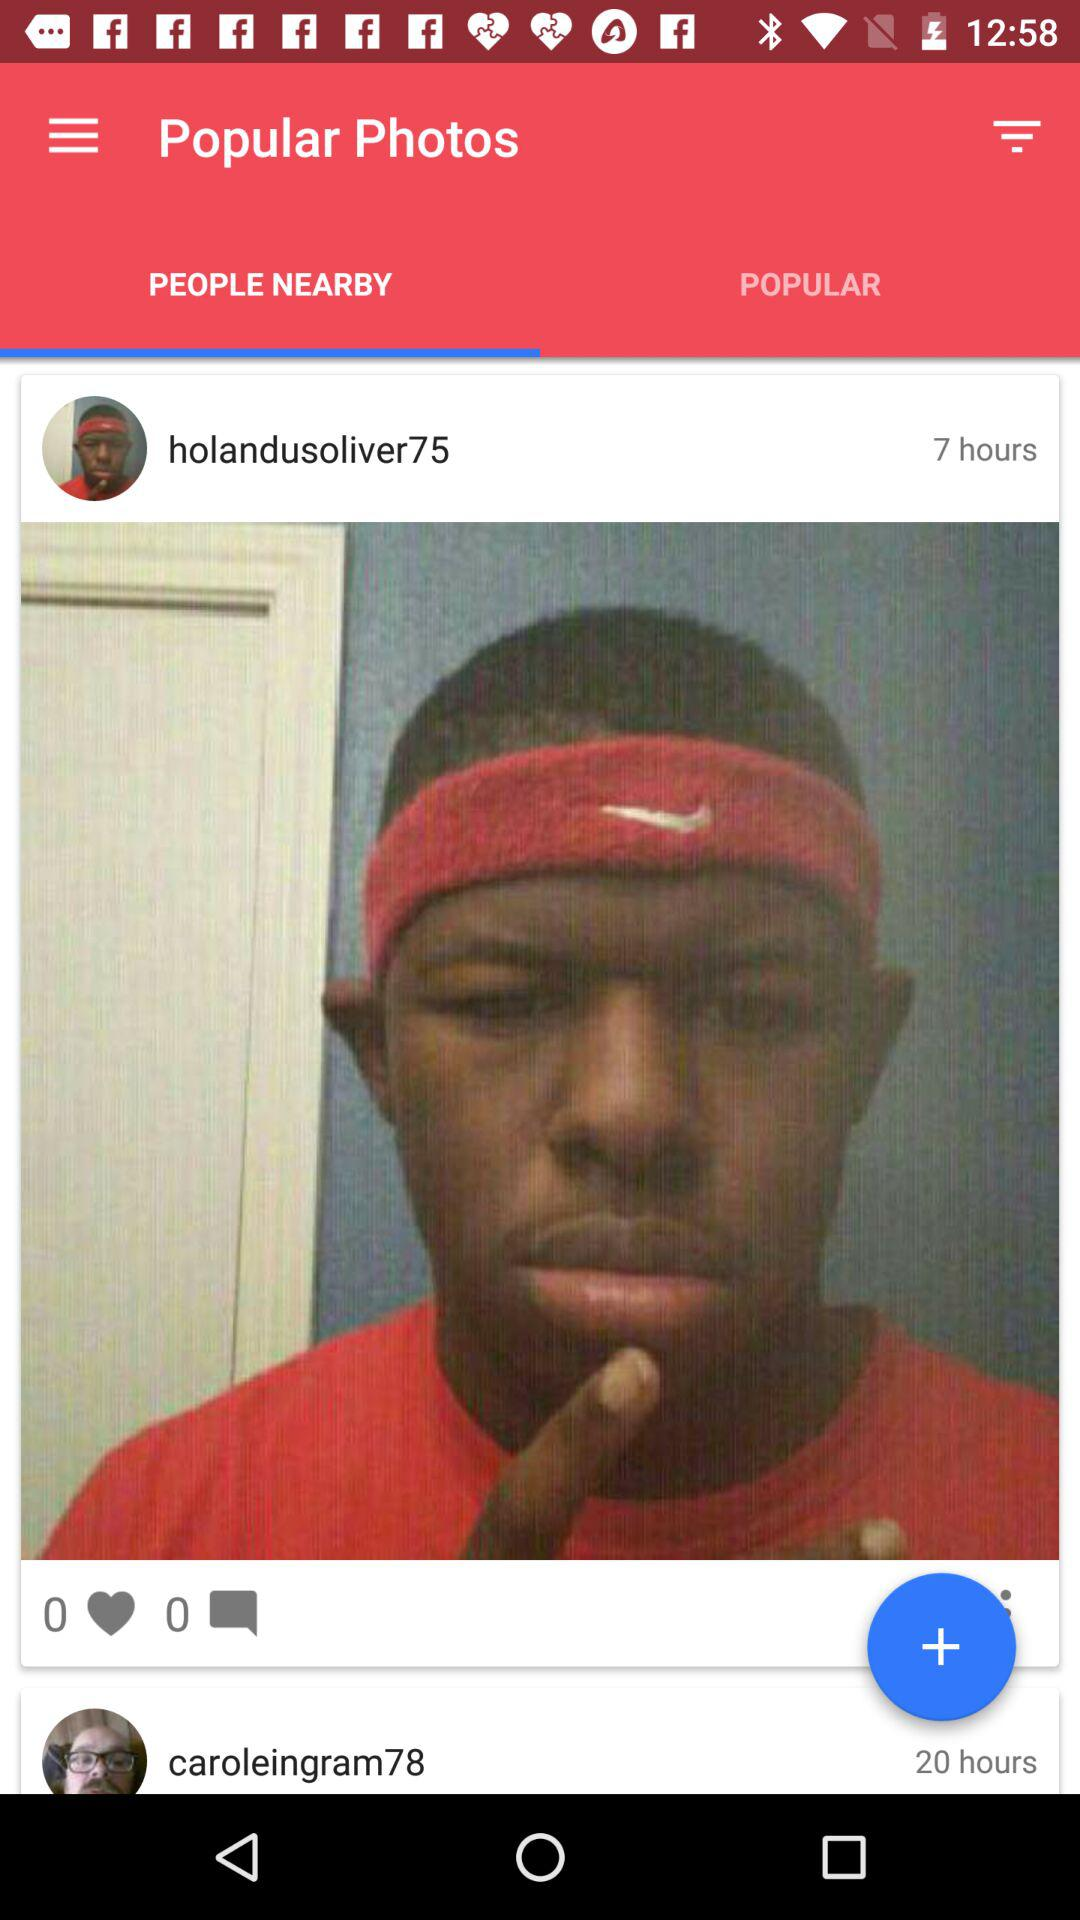How long ago did "holandusoliver75" post his photo? "holandusoliver75" posted his photo 7 hours ago. 